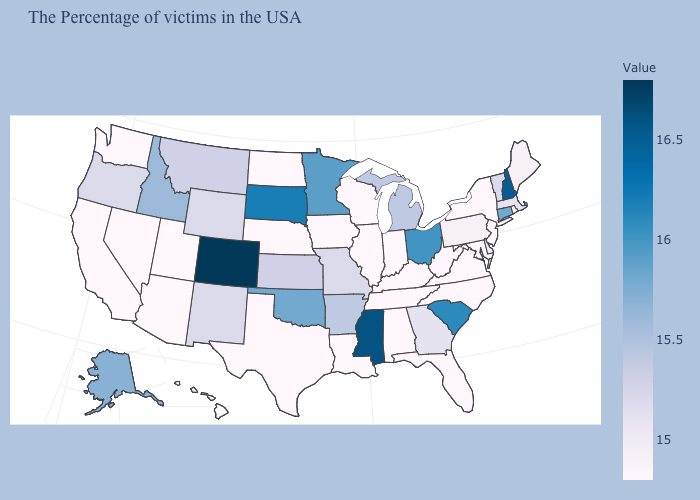Among the states that border Texas , which have the highest value?
Keep it brief. Oklahoma. Which states have the lowest value in the West?
Keep it brief. Utah, Arizona, Nevada, California, Washington, Hawaii. Among the states that border New Jersey , does Delaware have the highest value?
Short answer required. Yes. Among the states that border New Mexico , does Colorado have the highest value?
Quick response, please. Yes. Among the states that border Minnesota , does South Dakota have the highest value?
Answer briefly. Yes. 